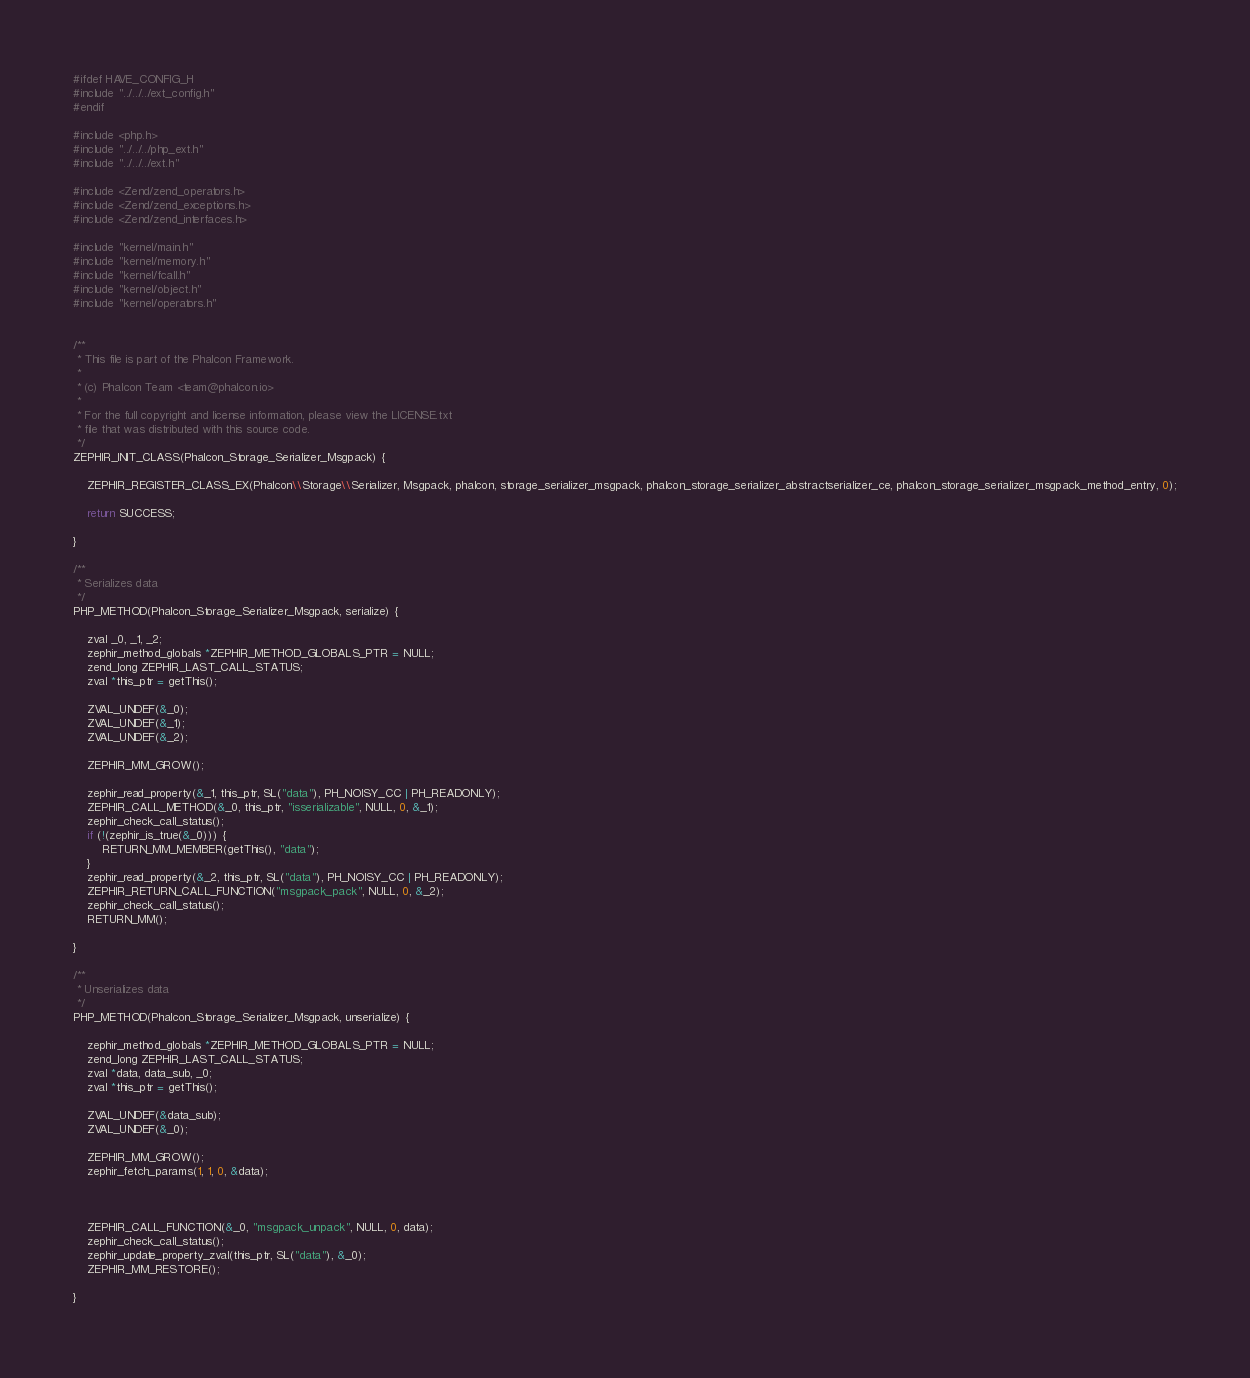<code> <loc_0><loc_0><loc_500><loc_500><_C_>
#ifdef HAVE_CONFIG_H
#include "../../../ext_config.h"
#endif

#include <php.h>
#include "../../../php_ext.h"
#include "../../../ext.h"

#include <Zend/zend_operators.h>
#include <Zend/zend_exceptions.h>
#include <Zend/zend_interfaces.h>

#include "kernel/main.h"
#include "kernel/memory.h"
#include "kernel/fcall.h"
#include "kernel/object.h"
#include "kernel/operators.h"


/**
 * This file is part of the Phalcon Framework.
 *
 * (c) Phalcon Team <team@phalcon.io>
 *
 * For the full copyright and license information, please view the LICENSE.txt
 * file that was distributed with this source code.
 */
ZEPHIR_INIT_CLASS(Phalcon_Storage_Serializer_Msgpack) {

	ZEPHIR_REGISTER_CLASS_EX(Phalcon\\Storage\\Serializer, Msgpack, phalcon, storage_serializer_msgpack, phalcon_storage_serializer_abstractserializer_ce, phalcon_storage_serializer_msgpack_method_entry, 0);

	return SUCCESS;

}

/**
 * Serializes data
 */
PHP_METHOD(Phalcon_Storage_Serializer_Msgpack, serialize) {

	zval _0, _1, _2;
	zephir_method_globals *ZEPHIR_METHOD_GLOBALS_PTR = NULL;
	zend_long ZEPHIR_LAST_CALL_STATUS;
	zval *this_ptr = getThis();

	ZVAL_UNDEF(&_0);
	ZVAL_UNDEF(&_1);
	ZVAL_UNDEF(&_2);

	ZEPHIR_MM_GROW();

	zephir_read_property(&_1, this_ptr, SL("data"), PH_NOISY_CC | PH_READONLY);
	ZEPHIR_CALL_METHOD(&_0, this_ptr, "isserializable", NULL, 0, &_1);
	zephir_check_call_status();
	if (!(zephir_is_true(&_0))) {
		RETURN_MM_MEMBER(getThis(), "data");
	}
	zephir_read_property(&_2, this_ptr, SL("data"), PH_NOISY_CC | PH_READONLY);
	ZEPHIR_RETURN_CALL_FUNCTION("msgpack_pack", NULL, 0, &_2);
	zephir_check_call_status();
	RETURN_MM();

}

/**
 * Unserializes data
 */
PHP_METHOD(Phalcon_Storage_Serializer_Msgpack, unserialize) {

	zephir_method_globals *ZEPHIR_METHOD_GLOBALS_PTR = NULL;
	zend_long ZEPHIR_LAST_CALL_STATUS;
	zval *data, data_sub, _0;
	zval *this_ptr = getThis();

	ZVAL_UNDEF(&data_sub);
	ZVAL_UNDEF(&_0);

	ZEPHIR_MM_GROW();
	zephir_fetch_params(1, 1, 0, &data);



	ZEPHIR_CALL_FUNCTION(&_0, "msgpack_unpack", NULL, 0, data);
	zephir_check_call_status();
	zephir_update_property_zval(this_ptr, SL("data"), &_0);
	ZEPHIR_MM_RESTORE();

}

</code> 